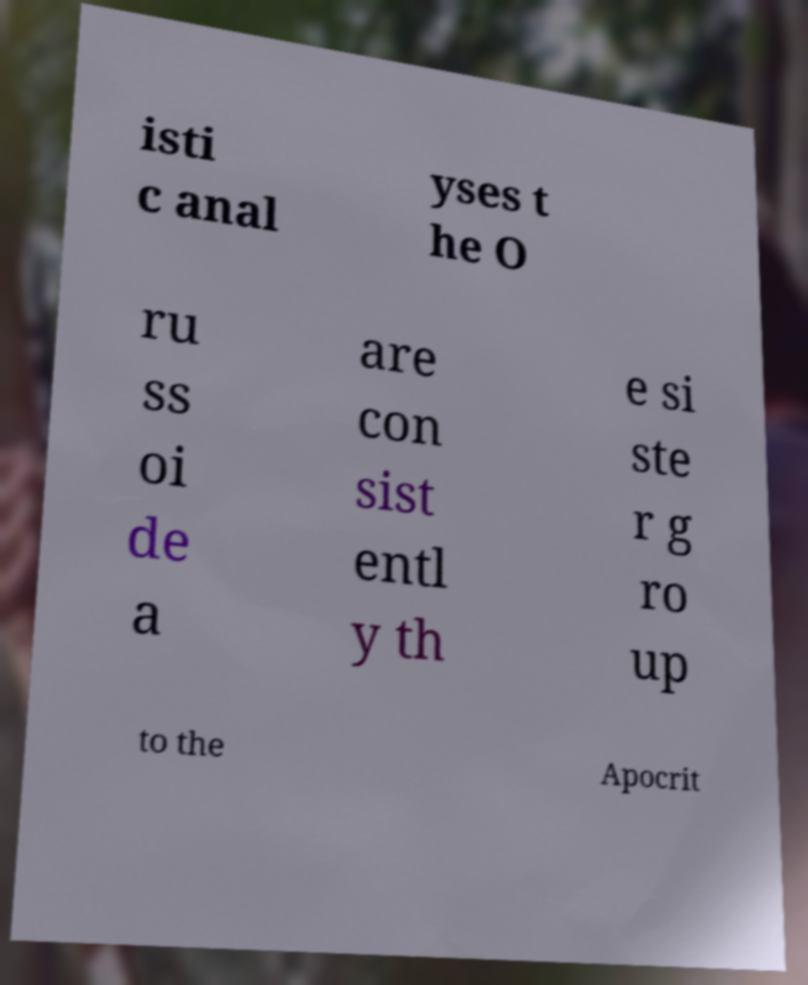Can you read and provide the text displayed in the image?This photo seems to have some interesting text. Can you extract and type it out for me? isti c anal yses t he O ru ss oi de a are con sist entl y th e si ste r g ro up to the Apocrit 